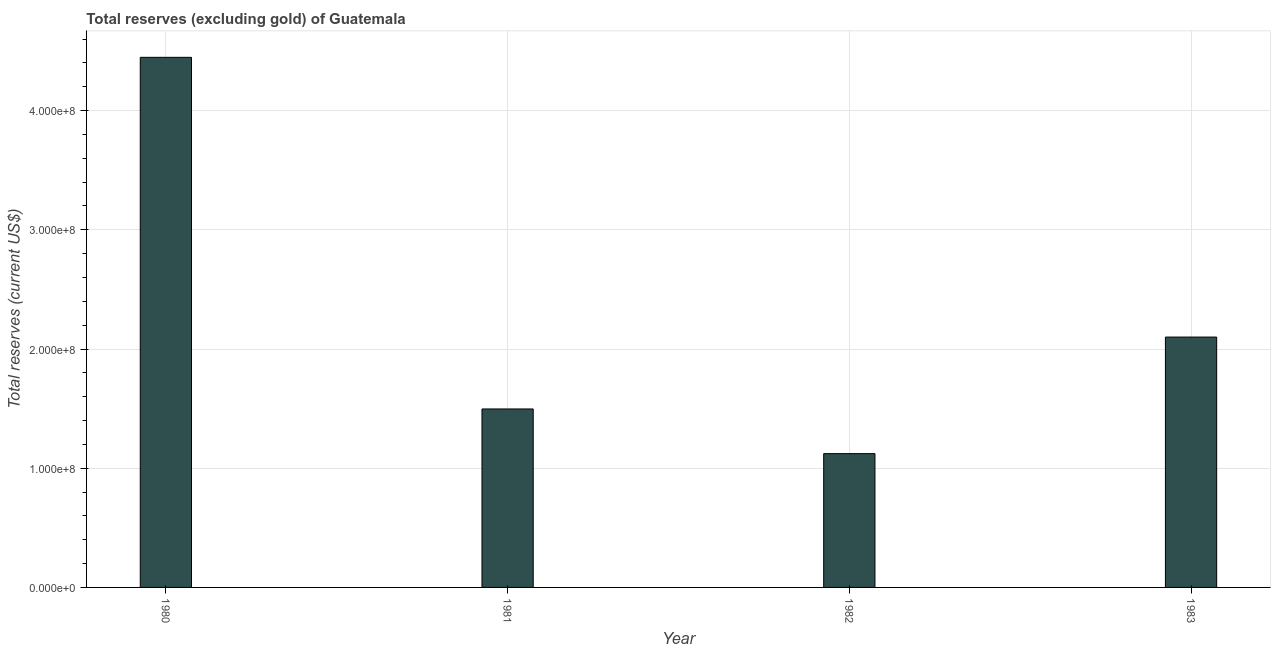Does the graph contain grids?
Your answer should be compact. Yes. What is the title of the graph?
Your answer should be compact. Total reserves (excluding gold) of Guatemala. What is the label or title of the Y-axis?
Your answer should be very brief. Total reserves (current US$). What is the total reserves (excluding gold) in 1981?
Give a very brief answer. 1.50e+08. Across all years, what is the maximum total reserves (excluding gold)?
Provide a short and direct response. 4.45e+08. Across all years, what is the minimum total reserves (excluding gold)?
Make the answer very short. 1.12e+08. In which year was the total reserves (excluding gold) minimum?
Provide a short and direct response. 1982. What is the sum of the total reserves (excluding gold)?
Give a very brief answer. 9.17e+08. What is the difference between the total reserves (excluding gold) in 1981 and 1982?
Offer a terse response. 3.75e+07. What is the average total reserves (excluding gold) per year?
Your answer should be compact. 2.29e+08. What is the median total reserves (excluding gold)?
Provide a short and direct response. 1.80e+08. What is the ratio of the total reserves (excluding gold) in 1980 to that in 1983?
Keep it short and to the point. 2.12. Is the difference between the total reserves (excluding gold) in 1981 and 1983 greater than the difference between any two years?
Provide a short and direct response. No. What is the difference between the highest and the second highest total reserves (excluding gold)?
Your answer should be very brief. 2.35e+08. What is the difference between the highest and the lowest total reserves (excluding gold)?
Provide a succinct answer. 3.32e+08. How many bars are there?
Offer a terse response. 4. How many years are there in the graph?
Keep it short and to the point. 4. What is the difference between two consecutive major ticks on the Y-axis?
Your answer should be very brief. 1.00e+08. What is the Total reserves (current US$) in 1980?
Keep it short and to the point. 4.45e+08. What is the Total reserves (current US$) of 1981?
Keep it short and to the point. 1.50e+08. What is the Total reserves (current US$) of 1982?
Make the answer very short. 1.12e+08. What is the Total reserves (current US$) of 1983?
Offer a very short reply. 2.10e+08. What is the difference between the Total reserves (current US$) in 1980 and 1981?
Ensure brevity in your answer.  2.95e+08. What is the difference between the Total reserves (current US$) in 1980 and 1982?
Your answer should be very brief. 3.32e+08. What is the difference between the Total reserves (current US$) in 1980 and 1983?
Provide a succinct answer. 2.35e+08. What is the difference between the Total reserves (current US$) in 1981 and 1982?
Offer a very short reply. 3.75e+07. What is the difference between the Total reserves (current US$) in 1981 and 1983?
Your answer should be compact. -6.03e+07. What is the difference between the Total reserves (current US$) in 1982 and 1983?
Offer a very short reply. -9.78e+07. What is the ratio of the Total reserves (current US$) in 1980 to that in 1981?
Offer a terse response. 2.97. What is the ratio of the Total reserves (current US$) in 1980 to that in 1982?
Your answer should be very brief. 3.96. What is the ratio of the Total reserves (current US$) in 1980 to that in 1983?
Your response must be concise. 2.12. What is the ratio of the Total reserves (current US$) in 1981 to that in 1982?
Ensure brevity in your answer.  1.33. What is the ratio of the Total reserves (current US$) in 1981 to that in 1983?
Offer a terse response. 0.71. What is the ratio of the Total reserves (current US$) in 1982 to that in 1983?
Offer a terse response. 0.53. 